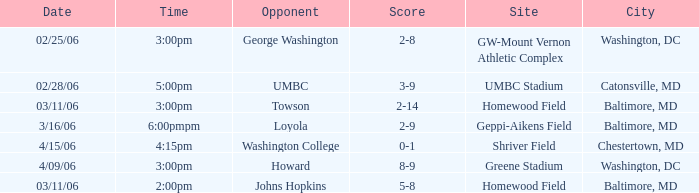Which site has a Score of 0-1? Shriver Field. 